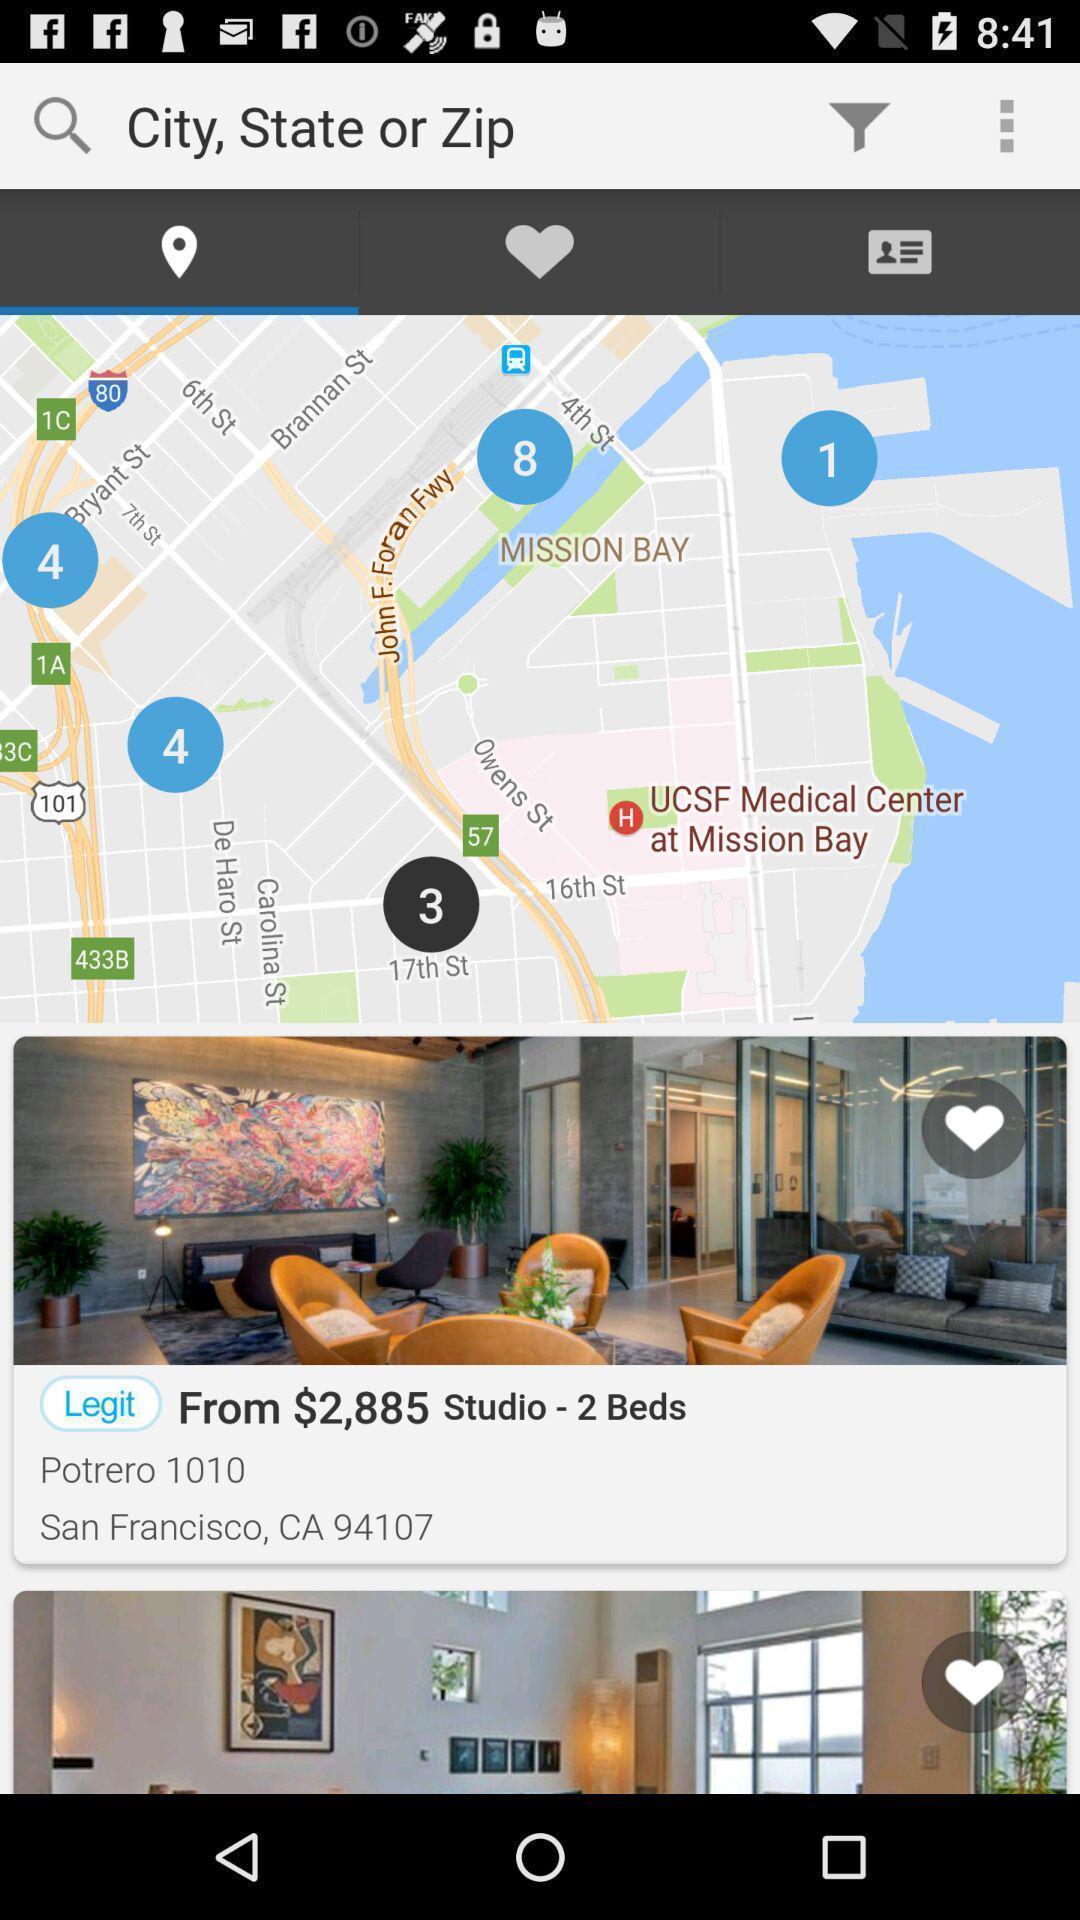Describe the content in this image. Screen displaying a map view and a search icon. 